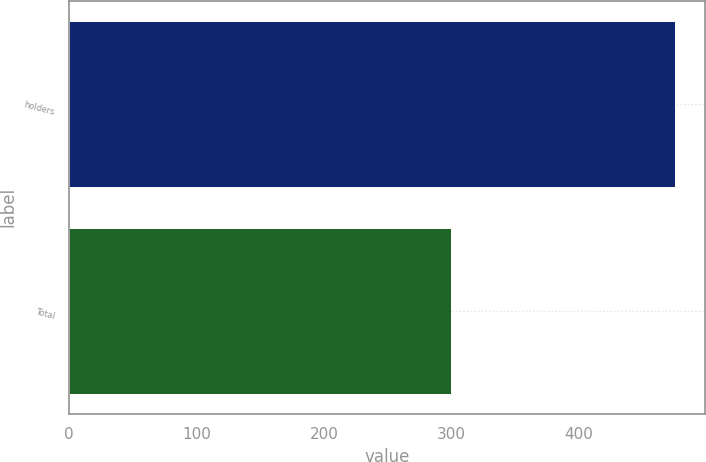<chart> <loc_0><loc_0><loc_500><loc_500><bar_chart><fcel>holders<fcel>Total<nl><fcel>475.51<fcel>299.81<nl></chart> 